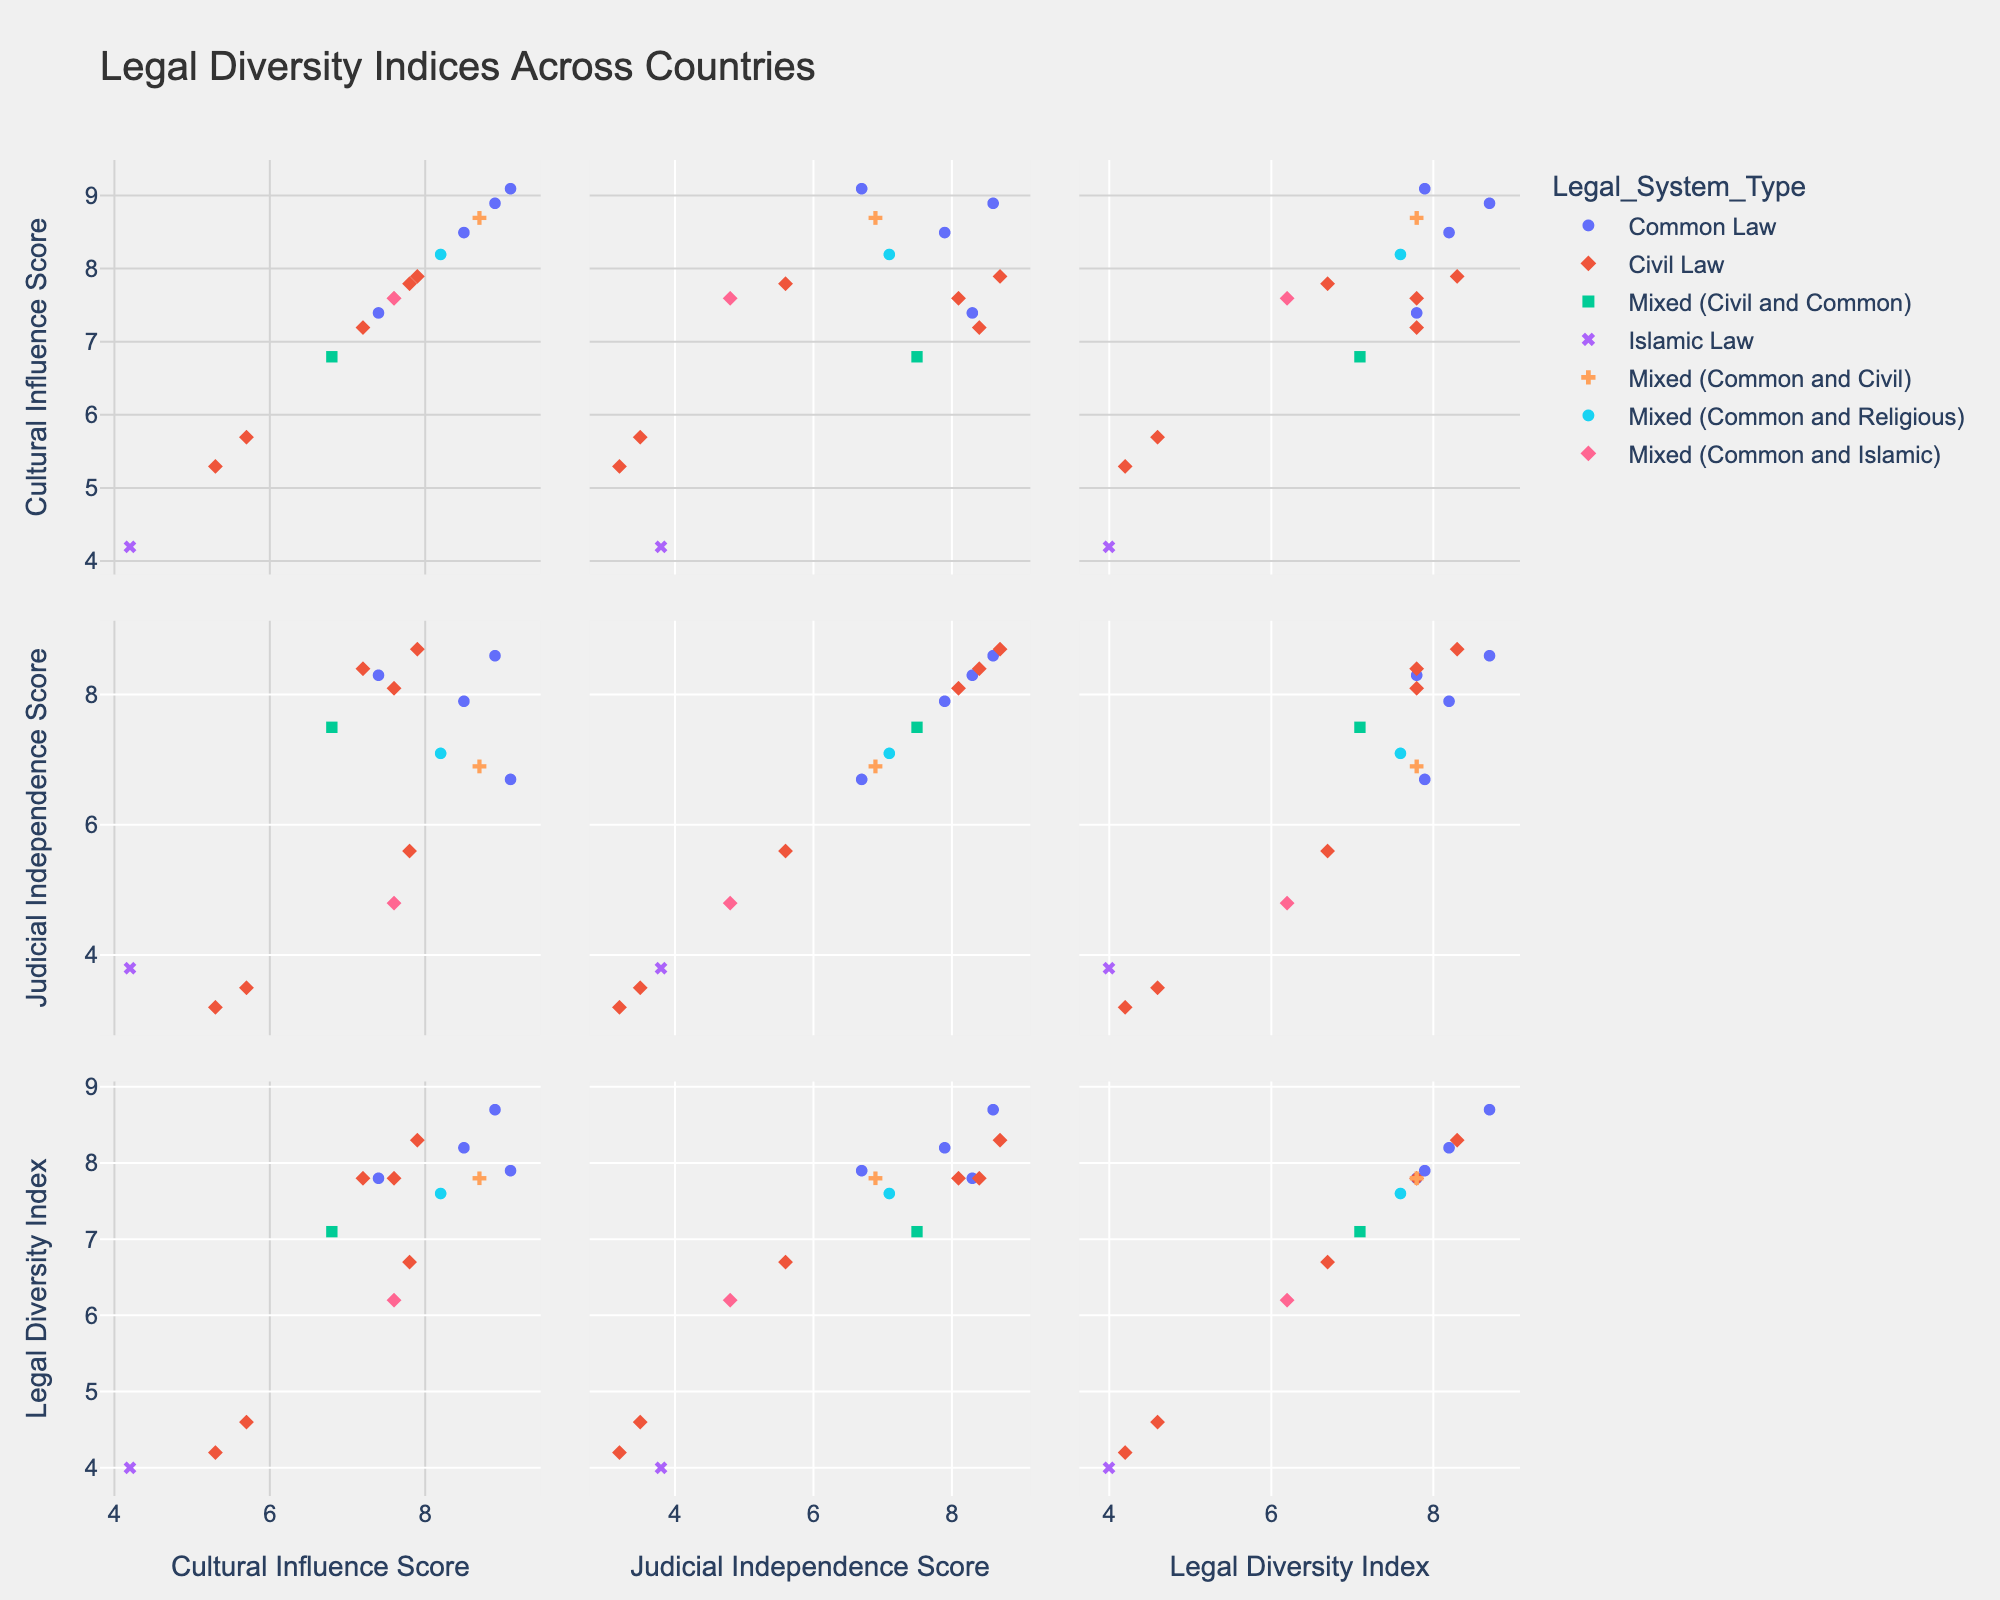How many countries have a Common Law legal system? Count the number of data points colored and symbolized for Common Law.
Answer: 5 Which country has the highest Legal Diversity Index? Locate the highest point on the Legal Diversity Index axis. That country will have the highest y value in the corresponding plot.
Answer: Canada Between South Africa and Brazil, which country has a higher Judicial Independence Score? Compare the Judicial Independence Scores of South Africa and Brazil. Locate each country’s point and compare the y-values in the `Judicial Independence Score` plot.
Answer: South Africa What's the average Cultural Influence Score of countries with a Civil Law legal system? Locate all countries with a Civil Law legal system. Sum their Cultural Influence Scores and divide by the number of countries. ((7.2 + 7.6 + 5.3 + 7.8 + 5.7 + 7.9) / 6)
Answer: 6.92 Is there a relationship between Cultural Influence Score and Judicial Independence Score? Look at the scatter plot of Cultural Influence Score vs. Judicial Independence Score. Observe if there is a trend or pattern.
Answer: Yes, generally positive Which legal system type has the widest range of Judicial Independence Scores? Compare the range (difference between max and min values) of Judicial Independence Scores for each legal system type.
Answer: Civil Law Do any countries have the same Cultural Influence Score but different Judicial Independence Scores? Identify points with the same x-value on the Cultural Influence Score axis but different y-values on the Judicial Independence Score axis.
Answer: Yes Which type of legal system appears to cluster around high values of Legal Diversity Index? Observe the scatter plot matrix and identify the color and symbol associated with high Legal Diversity Index values.
Answer: Common Law 